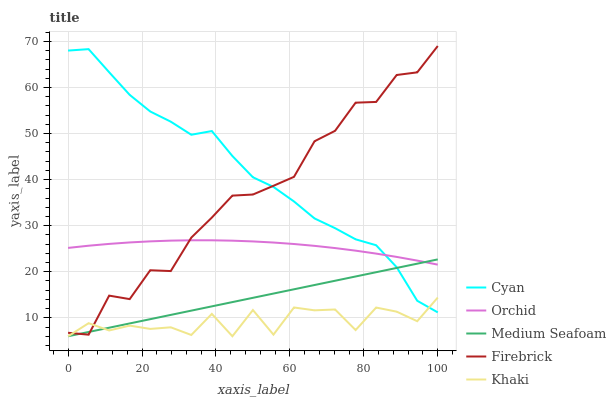Does Khaki have the minimum area under the curve?
Answer yes or no. Yes. Does Cyan have the maximum area under the curve?
Answer yes or no. Yes. Does Firebrick have the minimum area under the curve?
Answer yes or no. No. Does Firebrick have the maximum area under the curve?
Answer yes or no. No. Is Medium Seafoam the smoothest?
Answer yes or no. Yes. Is Khaki the roughest?
Answer yes or no. Yes. Is Firebrick the smoothest?
Answer yes or no. No. Is Firebrick the roughest?
Answer yes or no. No. Does Khaki have the lowest value?
Answer yes or no. Yes. Does Firebrick have the lowest value?
Answer yes or no. No. Does Firebrick have the highest value?
Answer yes or no. Yes. Does Khaki have the highest value?
Answer yes or no. No. Is Khaki less than Orchid?
Answer yes or no. Yes. Is Orchid greater than Khaki?
Answer yes or no. Yes. Does Medium Seafoam intersect Cyan?
Answer yes or no. Yes. Is Medium Seafoam less than Cyan?
Answer yes or no. No. Is Medium Seafoam greater than Cyan?
Answer yes or no. No. Does Khaki intersect Orchid?
Answer yes or no. No. 